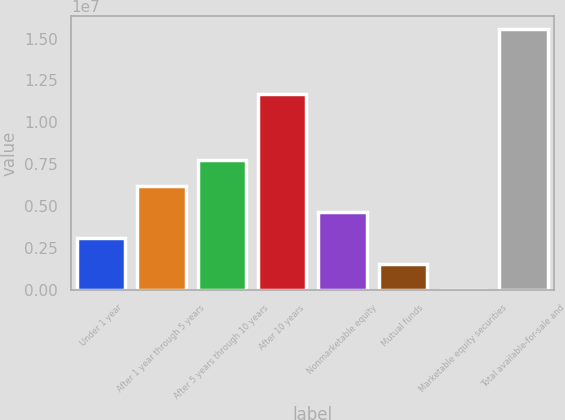Convert chart to OTSL. <chart><loc_0><loc_0><loc_500><loc_500><bar_chart><fcel>Under 1 year<fcel>After 1 year through 5 years<fcel>After 5 years through 10 years<fcel>After 10 years<fcel>Nonmarketable equity<fcel>Mutual funds<fcel>Marketable equity securities<fcel>Total available-for-sale and<nl><fcel>3.11361e+06<fcel>6.22592e+06<fcel>7.78207e+06<fcel>1.16652e+07<fcel>4.66976e+06<fcel>1.55746e+06<fcel>1302<fcel>1.55628e+07<nl></chart> 